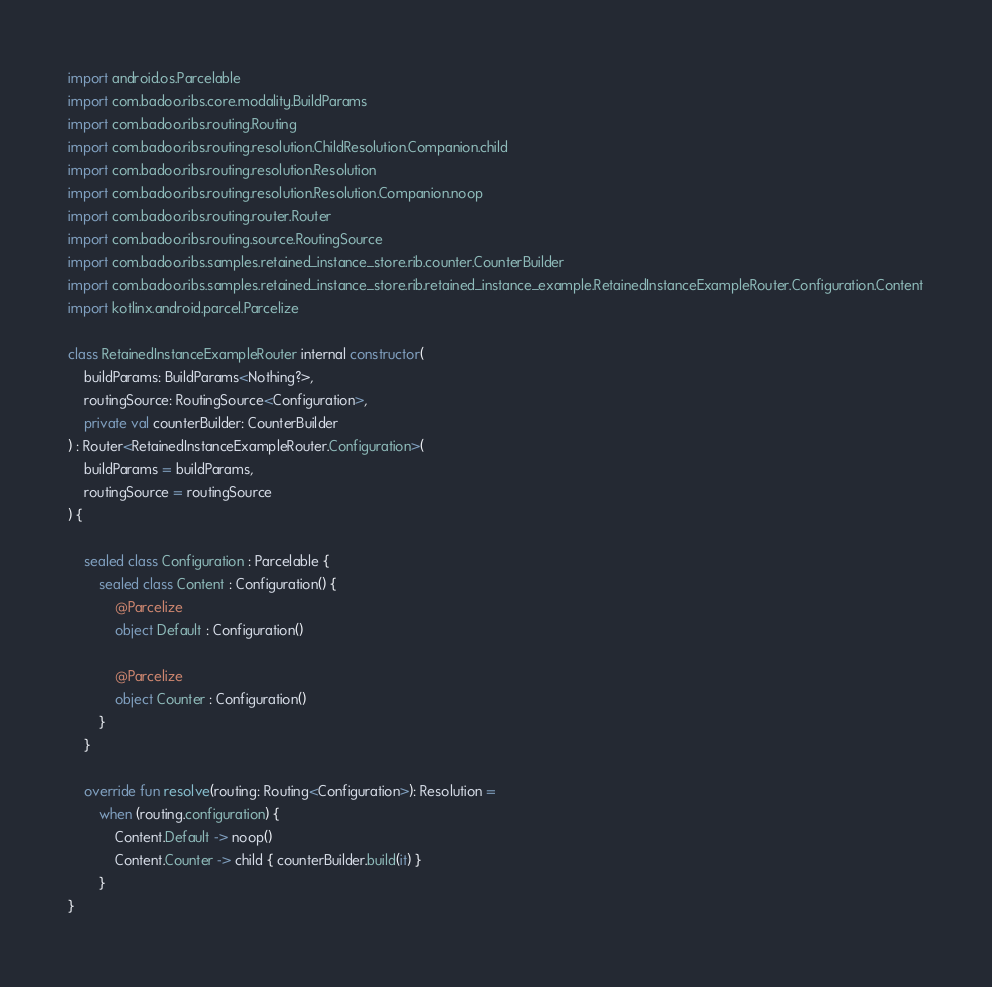Convert code to text. <code><loc_0><loc_0><loc_500><loc_500><_Kotlin_>import android.os.Parcelable
import com.badoo.ribs.core.modality.BuildParams
import com.badoo.ribs.routing.Routing
import com.badoo.ribs.routing.resolution.ChildResolution.Companion.child
import com.badoo.ribs.routing.resolution.Resolution
import com.badoo.ribs.routing.resolution.Resolution.Companion.noop
import com.badoo.ribs.routing.router.Router
import com.badoo.ribs.routing.source.RoutingSource
import com.badoo.ribs.samples.retained_instance_store.rib.counter.CounterBuilder
import com.badoo.ribs.samples.retained_instance_store.rib.retained_instance_example.RetainedInstanceExampleRouter.Configuration.Content
import kotlinx.android.parcel.Parcelize

class RetainedInstanceExampleRouter internal constructor(
    buildParams: BuildParams<Nothing?>,
    routingSource: RoutingSource<Configuration>,
    private val counterBuilder: CounterBuilder
) : Router<RetainedInstanceExampleRouter.Configuration>(
    buildParams = buildParams,
    routingSource = routingSource
) {

    sealed class Configuration : Parcelable {
        sealed class Content : Configuration() {
            @Parcelize
            object Default : Configuration()

            @Parcelize
            object Counter : Configuration()
        }
    }

    override fun resolve(routing: Routing<Configuration>): Resolution =
        when (routing.configuration) {
            Content.Default -> noop()
            Content.Counter -> child { counterBuilder.build(it) }
        }
}


</code> 